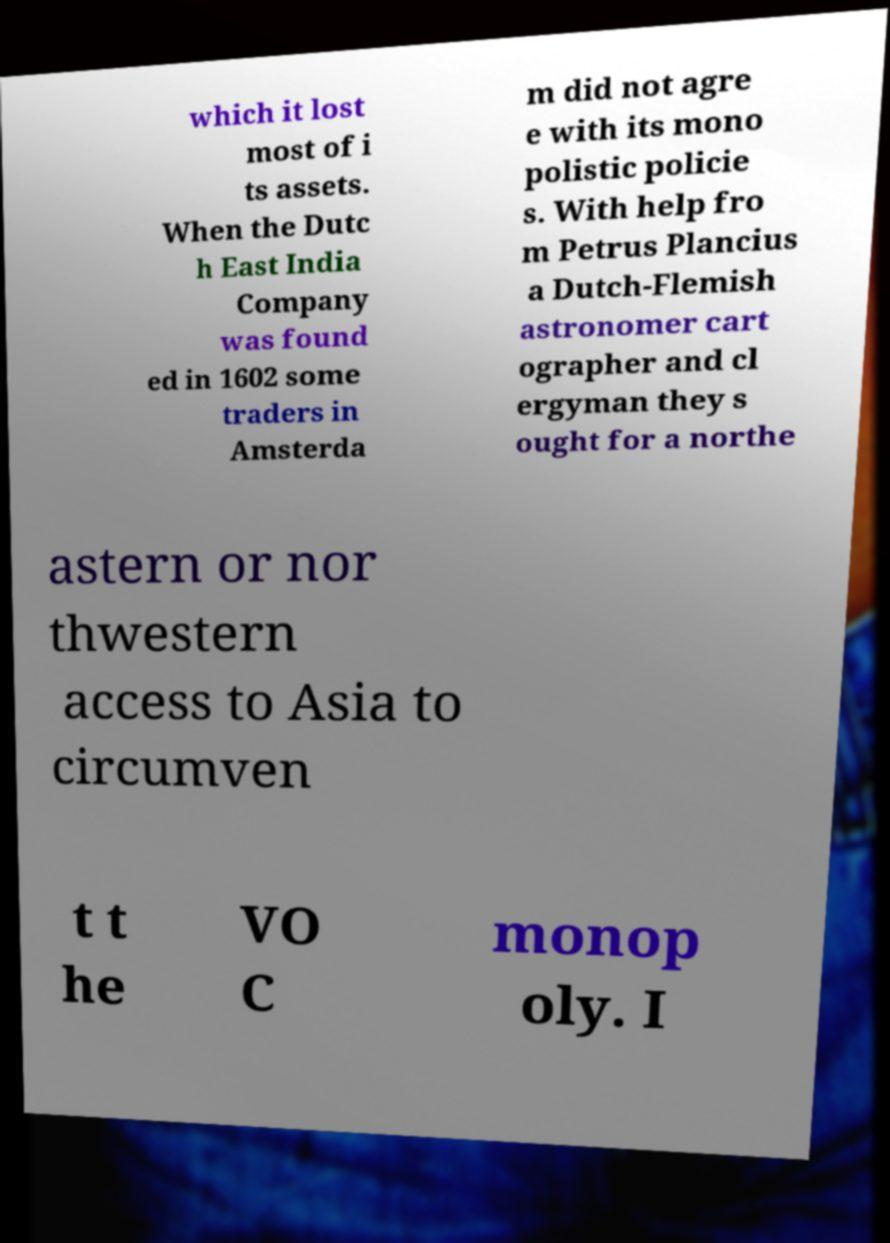Can you read and provide the text displayed in the image?This photo seems to have some interesting text. Can you extract and type it out for me? which it lost most of i ts assets. When the Dutc h East India Company was found ed in 1602 some traders in Amsterda m did not agre e with its mono polistic policie s. With help fro m Petrus Plancius a Dutch-Flemish astronomer cart ographer and cl ergyman they s ought for a northe astern or nor thwestern access to Asia to circumven t t he VO C monop oly. I 